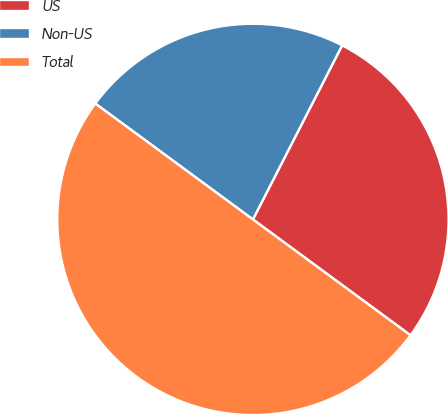Convert chart. <chart><loc_0><loc_0><loc_500><loc_500><pie_chart><fcel>US<fcel>Non-US<fcel>Total<nl><fcel>27.55%<fcel>22.45%<fcel>50.0%<nl></chart> 